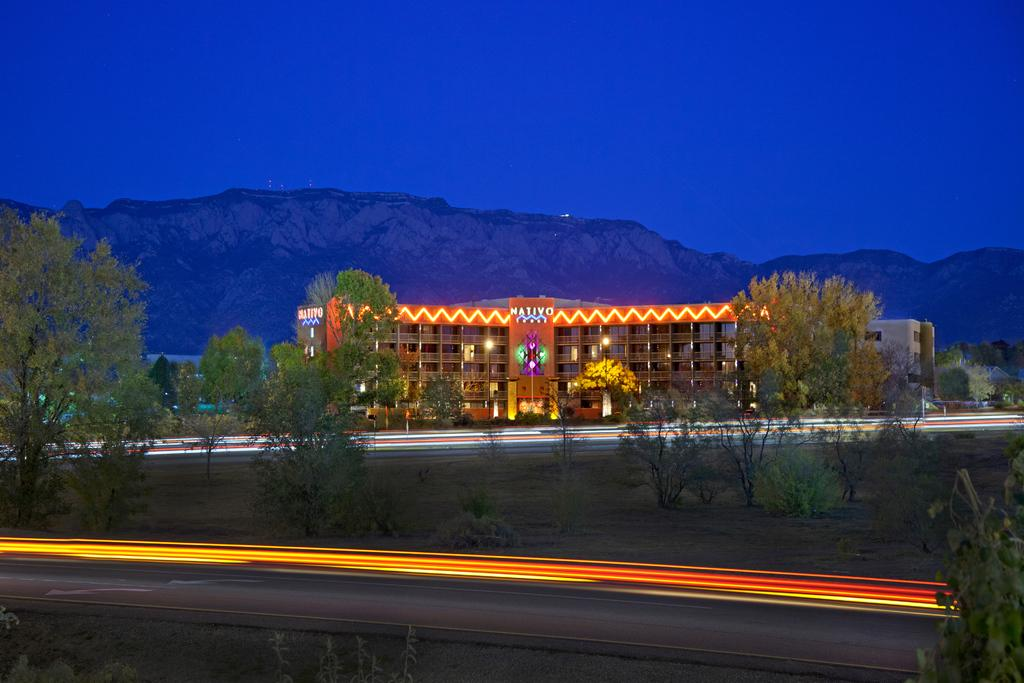What type of lights can be seen in the image? There are laser lights in the image. What type of natural vegetation is present in the image? There are trees and grass in the image. What type of man-made structure is present in the image? There is a building in the image. What type of illumination is present in the image? There are lights in the image. What type of geographical feature is present in the image? There is a hill in the image. What is the color of the sky in the image? The sky is blue in the image. What type of love can be seen in the image? There is no love present in the image; it features laser lights, trees, grass, a building, lights, a hill, and a blue sky. What type of tax is being paid by the trees in the image? There is no tax being paid by the trees in the image; trees do not pay taxes. 